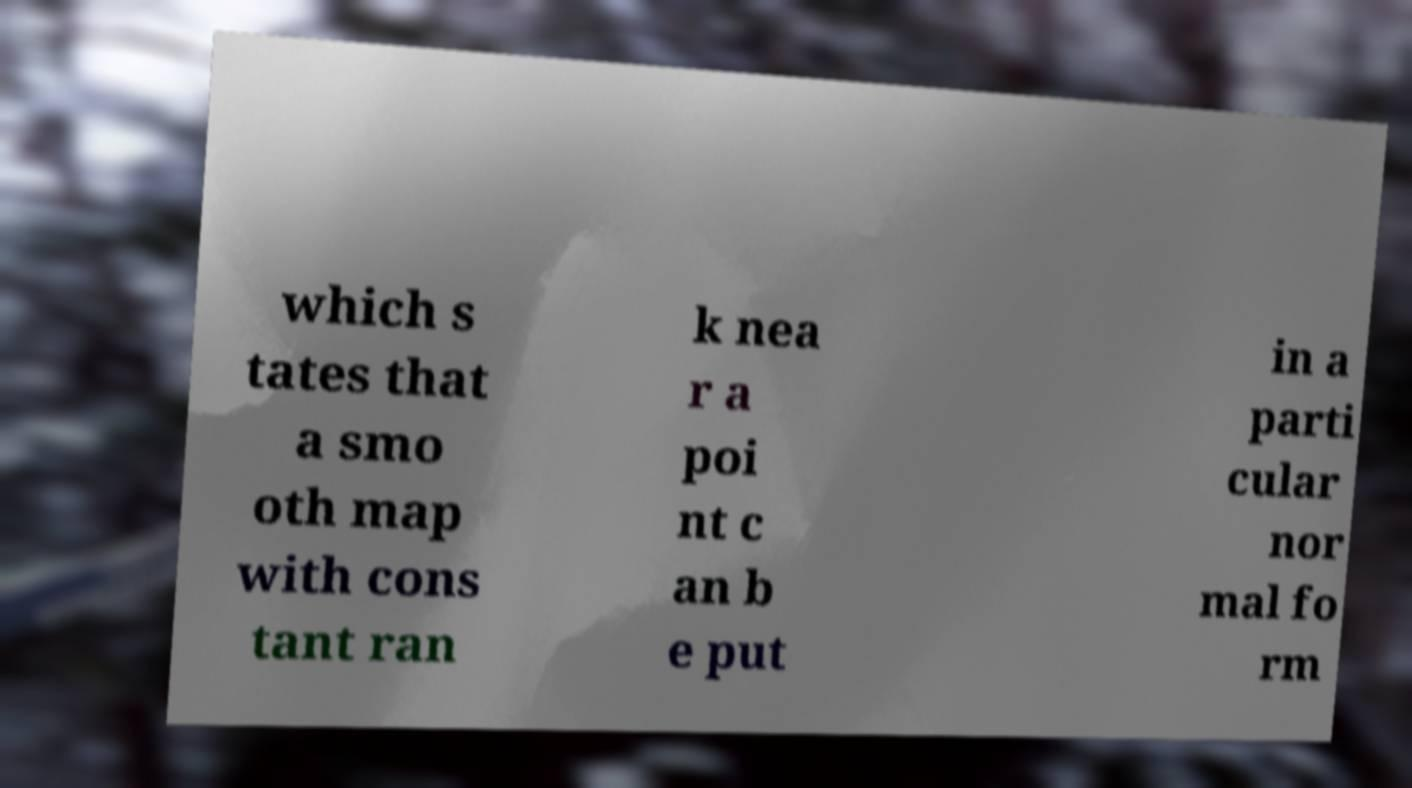I need the written content from this picture converted into text. Can you do that? which s tates that a smo oth map with cons tant ran k nea r a poi nt c an b e put in a parti cular nor mal fo rm 